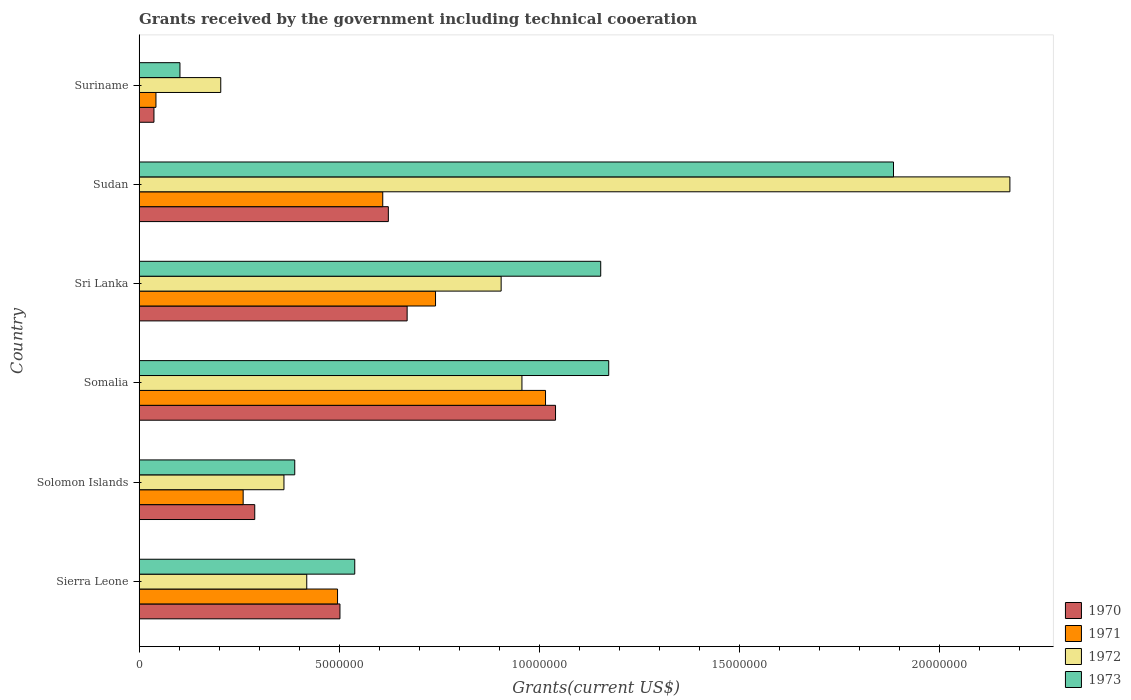How many different coloured bars are there?
Your answer should be very brief. 4. How many groups of bars are there?
Your answer should be very brief. 6. Are the number of bars per tick equal to the number of legend labels?
Provide a succinct answer. Yes. What is the label of the 6th group of bars from the top?
Offer a very short reply. Sierra Leone. In how many cases, is the number of bars for a given country not equal to the number of legend labels?
Offer a very short reply. 0. What is the total grants received by the government in 1970 in Sri Lanka?
Your answer should be very brief. 6.70e+06. Across all countries, what is the maximum total grants received by the government in 1970?
Offer a terse response. 1.04e+07. Across all countries, what is the minimum total grants received by the government in 1970?
Give a very brief answer. 3.70e+05. In which country was the total grants received by the government in 1972 maximum?
Offer a very short reply. Sudan. In which country was the total grants received by the government in 1972 minimum?
Ensure brevity in your answer.  Suriname. What is the total total grants received by the government in 1971 in the graph?
Offer a terse response. 3.16e+07. What is the difference between the total grants received by the government in 1973 in Sierra Leone and that in Sudan?
Your answer should be compact. -1.35e+07. What is the difference between the total grants received by the government in 1970 in Suriname and the total grants received by the government in 1971 in Sierra Leone?
Make the answer very short. -4.59e+06. What is the average total grants received by the government in 1972 per country?
Your answer should be very brief. 8.37e+06. What is the ratio of the total grants received by the government in 1973 in Sri Lanka to that in Sudan?
Your answer should be very brief. 0.61. What is the difference between the highest and the second highest total grants received by the government in 1973?
Your answer should be compact. 7.12e+06. What is the difference between the highest and the lowest total grants received by the government in 1971?
Provide a short and direct response. 9.74e+06. Is the sum of the total grants received by the government in 1973 in Sierra Leone and Sudan greater than the maximum total grants received by the government in 1972 across all countries?
Keep it short and to the point. Yes. Is it the case that in every country, the sum of the total grants received by the government in 1971 and total grants received by the government in 1973 is greater than the total grants received by the government in 1970?
Offer a terse response. Yes. What is the difference between two consecutive major ticks on the X-axis?
Provide a succinct answer. 5.00e+06. Are the values on the major ticks of X-axis written in scientific E-notation?
Offer a terse response. No. Does the graph contain any zero values?
Make the answer very short. No. Where does the legend appear in the graph?
Offer a terse response. Bottom right. How many legend labels are there?
Keep it short and to the point. 4. What is the title of the graph?
Keep it short and to the point. Grants received by the government including technical cooeration. Does "1961" appear as one of the legend labels in the graph?
Your answer should be very brief. No. What is the label or title of the X-axis?
Ensure brevity in your answer.  Grants(current US$). What is the label or title of the Y-axis?
Offer a terse response. Country. What is the Grants(current US$) in 1970 in Sierra Leone?
Your answer should be very brief. 5.02e+06. What is the Grants(current US$) in 1971 in Sierra Leone?
Keep it short and to the point. 4.96e+06. What is the Grants(current US$) of 1972 in Sierra Leone?
Make the answer very short. 4.19e+06. What is the Grants(current US$) of 1973 in Sierra Leone?
Offer a very short reply. 5.39e+06. What is the Grants(current US$) in 1970 in Solomon Islands?
Make the answer very short. 2.89e+06. What is the Grants(current US$) in 1971 in Solomon Islands?
Provide a succinct answer. 2.60e+06. What is the Grants(current US$) in 1972 in Solomon Islands?
Offer a terse response. 3.62e+06. What is the Grants(current US$) of 1973 in Solomon Islands?
Ensure brevity in your answer.  3.89e+06. What is the Grants(current US$) in 1970 in Somalia?
Make the answer very short. 1.04e+07. What is the Grants(current US$) of 1971 in Somalia?
Make the answer very short. 1.02e+07. What is the Grants(current US$) of 1972 in Somalia?
Ensure brevity in your answer.  9.57e+06. What is the Grants(current US$) in 1973 in Somalia?
Offer a terse response. 1.17e+07. What is the Grants(current US$) of 1970 in Sri Lanka?
Provide a short and direct response. 6.70e+06. What is the Grants(current US$) of 1971 in Sri Lanka?
Provide a succinct answer. 7.41e+06. What is the Grants(current US$) of 1972 in Sri Lanka?
Your answer should be very brief. 9.05e+06. What is the Grants(current US$) in 1973 in Sri Lanka?
Offer a terse response. 1.15e+07. What is the Grants(current US$) in 1970 in Sudan?
Your answer should be very brief. 6.23e+06. What is the Grants(current US$) in 1971 in Sudan?
Provide a succinct answer. 6.09e+06. What is the Grants(current US$) of 1972 in Sudan?
Offer a terse response. 2.18e+07. What is the Grants(current US$) in 1973 in Sudan?
Keep it short and to the point. 1.89e+07. What is the Grants(current US$) in 1970 in Suriname?
Your answer should be compact. 3.70e+05. What is the Grants(current US$) of 1971 in Suriname?
Give a very brief answer. 4.20e+05. What is the Grants(current US$) in 1972 in Suriname?
Your response must be concise. 2.04e+06. What is the Grants(current US$) of 1973 in Suriname?
Provide a succinct answer. 1.02e+06. Across all countries, what is the maximum Grants(current US$) of 1970?
Your answer should be very brief. 1.04e+07. Across all countries, what is the maximum Grants(current US$) in 1971?
Offer a terse response. 1.02e+07. Across all countries, what is the maximum Grants(current US$) in 1972?
Make the answer very short. 2.18e+07. Across all countries, what is the maximum Grants(current US$) of 1973?
Ensure brevity in your answer.  1.89e+07. Across all countries, what is the minimum Grants(current US$) in 1970?
Give a very brief answer. 3.70e+05. Across all countries, what is the minimum Grants(current US$) in 1971?
Make the answer very short. 4.20e+05. Across all countries, what is the minimum Grants(current US$) in 1972?
Provide a short and direct response. 2.04e+06. Across all countries, what is the minimum Grants(current US$) of 1973?
Make the answer very short. 1.02e+06. What is the total Grants(current US$) of 1970 in the graph?
Ensure brevity in your answer.  3.16e+07. What is the total Grants(current US$) in 1971 in the graph?
Provide a short and direct response. 3.16e+07. What is the total Grants(current US$) in 1972 in the graph?
Provide a short and direct response. 5.02e+07. What is the total Grants(current US$) in 1973 in the graph?
Offer a terse response. 5.24e+07. What is the difference between the Grants(current US$) in 1970 in Sierra Leone and that in Solomon Islands?
Provide a short and direct response. 2.13e+06. What is the difference between the Grants(current US$) of 1971 in Sierra Leone and that in Solomon Islands?
Your response must be concise. 2.36e+06. What is the difference between the Grants(current US$) of 1972 in Sierra Leone and that in Solomon Islands?
Provide a short and direct response. 5.70e+05. What is the difference between the Grants(current US$) of 1973 in Sierra Leone and that in Solomon Islands?
Give a very brief answer. 1.50e+06. What is the difference between the Grants(current US$) of 1970 in Sierra Leone and that in Somalia?
Your response must be concise. -5.39e+06. What is the difference between the Grants(current US$) in 1971 in Sierra Leone and that in Somalia?
Make the answer very short. -5.20e+06. What is the difference between the Grants(current US$) of 1972 in Sierra Leone and that in Somalia?
Make the answer very short. -5.38e+06. What is the difference between the Grants(current US$) in 1973 in Sierra Leone and that in Somalia?
Your answer should be compact. -6.35e+06. What is the difference between the Grants(current US$) in 1970 in Sierra Leone and that in Sri Lanka?
Provide a succinct answer. -1.68e+06. What is the difference between the Grants(current US$) in 1971 in Sierra Leone and that in Sri Lanka?
Make the answer very short. -2.45e+06. What is the difference between the Grants(current US$) in 1972 in Sierra Leone and that in Sri Lanka?
Give a very brief answer. -4.86e+06. What is the difference between the Grants(current US$) in 1973 in Sierra Leone and that in Sri Lanka?
Provide a short and direct response. -6.15e+06. What is the difference between the Grants(current US$) of 1970 in Sierra Leone and that in Sudan?
Ensure brevity in your answer.  -1.21e+06. What is the difference between the Grants(current US$) of 1971 in Sierra Leone and that in Sudan?
Provide a succinct answer. -1.13e+06. What is the difference between the Grants(current US$) in 1972 in Sierra Leone and that in Sudan?
Your answer should be very brief. -1.76e+07. What is the difference between the Grants(current US$) of 1973 in Sierra Leone and that in Sudan?
Provide a short and direct response. -1.35e+07. What is the difference between the Grants(current US$) of 1970 in Sierra Leone and that in Suriname?
Offer a terse response. 4.65e+06. What is the difference between the Grants(current US$) of 1971 in Sierra Leone and that in Suriname?
Keep it short and to the point. 4.54e+06. What is the difference between the Grants(current US$) in 1972 in Sierra Leone and that in Suriname?
Your response must be concise. 2.15e+06. What is the difference between the Grants(current US$) in 1973 in Sierra Leone and that in Suriname?
Ensure brevity in your answer.  4.37e+06. What is the difference between the Grants(current US$) of 1970 in Solomon Islands and that in Somalia?
Your answer should be very brief. -7.52e+06. What is the difference between the Grants(current US$) in 1971 in Solomon Islands and that in Somalia?
Offer a very short reply. -7.56e+06. What is the difference between the Grants(current US$) of 1972 in Solomon Islands and that in Somalia?
Ensure brevity in your answer.  -5.95e+06. What is the difference between the Grants(current US$) in 1973 in Solomon Islands and that in Somalia?
Offer a terse response. -7.85e+06. What is the difference between the Grants(current US$) of 1970 in Solomon Islands and that in Sri Lanka?
Keep it short and to the point. -3.81e+06. What is the difference between the Grants(current US$) in 1971 in Solomon Islands and that in Sri Lanka?
Your answer should be compact. -4.81e+06. What is the difference between the Grants(current US$) in 1972 in Solomon Islands and that in Sri Lanka?
Your answer should be very brief. -5.43e+06. What is the difference between the Grants(current US$) of 1973 in Solomon Islands and that in Sri Lanka?
Offer a terse response. -7.65e+06. What is the difference between the Grants(current US$) in 1970 in Solomon Islands and that in Sudan?
Provide a short and direct response. -3.34e+06. What is the difference between the Grants(current US$) in 1971 in Solomon Islands and that in Sudan?
Provide a short and direct response. -3.49e+06. What is the difference between the Grants(current US$) of 1972 in Solomon Islands and that in Sudan?
Make the answer very short. -1.82e+07. What is the difference between the Grants(current US$) of 1973 in Solomon Islands and that in Sudan?
Your answer should be very brief. -1.50e+07. What is the difference between the Grants(current US$) in 1970 in Solomon Islands and that in Suriname?
Your response must be concise. 2.52e+06. What is the difference between the Grants(current US$) of 1971 in Solomon Islands and that in Suriname?
Keep it short and to the point. 2.18e+06. What is the difference between the Grants(current US$) of 1972 in Solomon Islands and that in Suriname?
Your response must be concise. 1.58e+06. What is the difference between the Grants(current US$) of 1973 in Solomon Islands and that in Suriname?
Keep it short and to the point. 2.87e+06. What is the difference between the Grants(current US$) of 1970 in Somalia and that in Sri Lanka?
Ensure brevity in your answer.  3.71e+06. What is the difference between the Grants(current US$) in 1971 in Somalia and that in Sri Lanka?
Ensure brevity in your answer.  2.75e+06. What is the difference between the Grants(current US$) in 1972 in Somalia and that in Sri Lanka?
Ensure brevity in your answer.  5.20e+05. What is the difference between the Grants(current US$) of 1973 in Somalia and that in Sri Lanka?
Provide a succinct answer. 2.00e+05. What is the difference between the Grants(current US$) of 1970 in Somalia and that in Sudan?
Ensure brevity in your answer.  4.18e+06. What is the difference between the Grants(current US$) in 1971 in Somalia and that in Sudan?
Keep it short and to the point. 4.07e+06. What is the difference between the Grants(current US$) in 1972 in Somalia and that in Sudan?
Provide a short and direct response. -1.22e+07. What is the difference between the Grants(current US$) of 1973 in Somalia and that in Sudan?
Keep it short and to the point. -7.12e+06. What is the difference between the Grants(current US$) in 1970 in Somalia and that in Suriname?
Offer a terse response. 1.00e+07. What is the difference between the Grants(current US$) in 1971 in Somalia and that in Suriname?
Keep it short and to the point. 9.74e+06. What is the difference between the Grants(current US$) in 1972 in Somalia and that in Suriname?
Provide a succinct answer. 7.53e+06. What is the difference between the Grants(current US$) of 1973 in Somalia and that in Suriname?
Your answer should be very brief. 1.07e+07. What is the difference between the Grants(current US$) in 1971 in Sri Lanka and that in Sudan?
Give a very brief answer. 1.32e+06. What is the difference between the Grants(current US$) in 1972 in Sri Lanka and that in Sudan?
Make the answer very short. -1.27e+07. What is the difference between the Grants(current US$) of 1973 in Sri Lanka and that in Sudan?
Offer a very short reply. -7.32e+06. What is the difference between the Grants(current US$) in 1970 in Sri Lanka and that in Suriname?
Your answer should be very brief. 6.33e+06. What is the difference between the Grants(current US$) in 1971 in Sri Lanka and that in Suriname?
Keep it short and to the point. 6.99e+06. What is the difference between the Grants(current US$) in 1972 in Sri Lanka and that in Suriname?
Your answer should be compact. 7.01e+06. What is the difference between the Grants(current US$) of 1973 in Sri Lanka and that in Suriname?
Give a very brief answer. 1.05e+07. What is the difference between the Grants(current US$) in 1970 in Sudan and that in Suriname?
Your answer should be very brief. 5.86e+06. What is the difference between the Grants(current US$) of 1971 in Sudan and that in Suriname?
Offer a very short reply. 5.67e+06. What is the difference between the Grants(current US$) of 1972 in Sudan and that in Suriname?
Ensure brevity in your answer.  1.97e+07. What is the difference between the Grants(current US$) of 1973 in Sudan and that in Suriname?
Ensure brevity in your answer.  1.78e+07. What is the difference between the Grants(current US$) in 1970 in Sierra Leone and the Grants(current US$) in 1971 in Solomon Islands?
Your answer should be very brief. 2.42e+06. What is the difference between the Grants(current US$) of 1970 in Sierra Leone and the Grants(current US$) of 1972 in Solomon Islands?
Offer a terse response. 1.40e+06. What is the difference between the Grants(current US$) of 1970 in Sierra Leone and the Grants(current US$) of 1973 in Solomon Islands?
Your answer should be very brief. 1.13e+06. What is the difference between the Grants(current US$) of 1971 in Sierra Leone and the Grants(current US$) of 1972 in Solomon Islands?
Make the answer very short. 1.34e+06. What is the difference between the Grants(current US$) in 1971 in Sierra Leone and the Grants(current US$) in 1973 in Solomon Islands?
Provide a short and direct response. 1.07e+06. What is the difference between the Grants(current US$) in 1972 in Sierra Leone and the Grants(current US$) in 1973 in Solomon Islands?
Make the answer very short. 3.00e+05. What is the difference between the Grants(current US$) in 1970 in Sierra Leone and the Grants(current US$) in 1971 in Somalia?
Provide a succinct answer. -5.14e+06. What is the difference between the Grants(current US$) of 1970 in Sierra Leone and the Grants(current US$) of 1972 in Somalia?
Your answer should be compact. -4.55e+06. What is the difference between the Grants(current US$) of 1970 in Sierra Leone and the Grants(current US$) of 1973 in Somalia?
Offer a terse response. -6.72e+06. What is the difference between the Grants(current US$) in 1971 in Sierra Leone and the Grants(current US$) in 1972 in Somalia?
Offer a terse response. -4.61e+06. What is the difference between the Grants(current US$) in 1971 in Sierra Leone and the Grants(current US$) in 1973 in Somalia?
Provide a short and direct response. -6.78e+06. What is the difference between the Grants(current US$) of 1972 in Sierra Leone and the Grants(current US$) of 1973 in Somalia?
Your response must be concise. -7.55e+06. What is the difference between the Grants(current US$) of 1970 in Sierra Leone and the Grants(current US$) of 1971 in Sri Lanka?
Give a very brief answer. -2.39e+06. What is the difference between the Grants(current US$) of 1970 in Sierra Leone and the Grants(current US$) of 1972 in Sri Lanka?
Ensure brevity in your answer.  -4.03e+06. What is the difference between the Grants(current US$) in 1970 in Sierra Leone and the Grants(current US$) in 1973 in Sri Lanka?
Keep it short and to the point. -6.52e+06. What is the difference between the Grants(current US$) in 1971 in Sierra Leone and the Grants(current US$) in 1972 in Sri Lanka?
Your response must be concise. -4.09e+06. What is the difference between the Grants(current US$) of 1971 in Sierra Leone and the Grants(current US$) of 1973 in Sri Lanka?
Offer a very short reply. -6.58e+06. What is the difference between the Grants(current US$) in 1972 in Sierra Leone and the Grants(current US$) in 1973 in Sri Lanka?
Your response must be concise. -7.35e+06. What is the difference between the Grants(current US$) in 1970 in Sierra Leone and the Grants(current US$) in 1971 in Sudan?
Provide a short and direct response. -1.07e+06. What is the difference between the Grants(current US$) in 1970 in Sierra Leone and the Grants(current US$) in 1972 in Sudan?
Your response must be concise. -1.68e+07. What is the difference between the Grants(current US$) in 1970 in Sierra Leone and the Grants(current US$) in 1973 in Sudan?
Your response must be concise. -1.38e+07. What is the difference between the Grants(current US$) of 1971 in Sierra Leone and the Grants(current US$) of 1972 in Sudan?
Make the answer very short. -1.68e+07. What is the difference between the Grants(current US$) in 1971 in Sierra Leone and the Grants(current US$) in 1973 in Sudan?
Offer a terse response. -1.39e+07. What is the difference between the Grants(current US$) in 1972 in Sierra Leone and the Grants(current US$) in 1973 in Sudan?
Keep it short and to the point. -1.47e+07. What is the difference between the Grants(current US$) of 1970 in Sierra Leone and the Grants(current US$) of 1971 in Suriname?
Your answer should be very brief. 4.60e+06. What is the difference between the Grants(current US$) of 1970 in Sierra Leone and the Grants(current US$) of 1972 in Suriname?
Your answer should be compact. 2.98e+06. What is the difference between the Grants(current US$) of 1970 in Sierra Leone and the Grants(current US$) of 1973 in Suriname?
Your answer should be compact. 4.00e+06. What is the difference between the Grants(current US$) of 1971 in Sierra Leone and the Grants(current US$) of 1972 in Suriname?
Keep it short and to the point. 2.92e+06. What is the difference between the Grants(current US$) in 1971 in Sierra Leone and the Grants(current US$) in 1973 in Suriname?
Your answer should be compact. 3.94e+06. What is the difference between the Grants(current US$) in 1972 in Sierra Leone and the Grants(current US$) in 1973 in Suriname?
Offer a terse response. 3.17e+06. What is the difference between the Grants(current US$) of 1970 in Solomon Islands and the Grants(current US$) of 1971 in Somalia?
Your answer should be compact. -7.27e+06. What is the difference between the Grants(current US$) of 1970 in Solomon Islands and the Grants(current US$) of 1972 in Somalia?
Ensure brevity in your answer.  -6.68e+06. What is the difference between the Grants(current US$) of 1970 in Solomon Islands and the Grants(current US$) of 1973 in Somalia?
Give a very brief answer. -8.85e+06. What is the difference between the Grants(current US$) in 1971 in Solomon Islands and the Grants(current US$) in 1972 in Somalia?
Ensure brevity in your answer.  -6.97e+06. What is the difference between the Grants(current US$) of 1971 in Solomon Islands and the Grants(current US$) of 1973 in Somalia?
Give a very brief answer. -9.14e+06. What is the difference between the Grants(current US$) of 1972 in Solomon Islands and the Grants(current US$) of 1973 in Somalia?
Offer a very short reply. -8.12e+06. What is the difference between the Grants(current US$) of 1970 in Solomon Islands and the Grants(current US$) of 1971 in Sri Lanka?
Make the answer very short. -4.52e+06. What is the difference between the Grants(current US$) of 1970 in Solomon Islands and the Grants(current US$) of 1972 in Sri Lanka?
Provide a succinct answer. -6.16e+06. What is the difference between the Grants(current US$) of 1970 in Solomon Islands and the Grants(current US$) of 1973 in Sri Lanka?
Give a very brief answer. -8.65e+06. What is the difference between the Grants(current US$) of 1971 in Solomon Islands and the Grants(current US$) of 1972 in Sri Lanka?
Keep it short and to the point. -6.45e+06. What is the difference between the Grants(current US$) of 1971 in Solomon Islands and the Grants(current US$) of 1973 in Sri Lanka?
Make the answer very short. -8.94e+06. What is the difference between the Grants(current US$) in 1972 in Solomon Islands and the Grants(current US$) in 1973 in Sri Lanka?
Your answer should be compact. -7.92e+06. What is the difference between the Grants(current US$) of 1970 in Solomon Islands and the Grants(current US$) of 1971 in Sudan?
Provide a short and direct response. -3.20e+06. What is the difference between the Grants(current US$) of 1970 in Solomon Islands and the Grants(current US$) of 1972 in Sudan?
Your response must be concise. -1.89e+07. What is the difference between the Grants(current US$) in 1970 in Solomon Islands and the Grants(current US$) in 1973 in Sudan?
Offer a terse response. -1.60e+07. What is the difference between the Grants(current US$) of 1971 in Solomon Islands and the Grants(current US$) of 1972 in Sudan?
Give a very brief answer. -1.92e+07. What is the difference between the Grants(current US$) of 1971 in Solomon Islands and the Grants(current US$) of 1973 in Sudan?
Ensure brevity in your answer.  -1.63e+07. What is the difference between the Grants(current US$) of 1972 in Solomon Islands and the Grants(current US$) of 1973 in Sudan?
Provide a succinct answer. -1.52e+07. What is the difference between the Grants(current US$) in 1970 in Solomon Islands and the Grants(current US$) in 1971 in Suriname?
Your answer should be very brief. 2.47e+06. What is the difference between the Grants(current US$) in 1970 in Solomon Islands and the Grants(current US$) in 1972 in Suriname?
Provide a short and direct response. 8.50e+05. What is the difference between the Grants(current US$) in 1970 in Solomon Islands and the Grants(current US$) in 1973 in Suriname?
Keep it short and to the point. 1.87e+06. What is the difference between the Grants(current US$) of 1971 in Solomon Islands and the Grants(current US$) of 1972 in Suriname?
Offer a very short reply. 5.60e+05. What is the difference between the Grants(current US$) in 1971 in Solomon Islands and the Grants(current US$) in 1973 in Suriname?
Provide a short and direct response. 1.58e+06. What is the difference between the Grants(current US$) of 1972 in Solomon Islands and the Grants(current US$) of 1973 in Suriname?
Provide a succinct answer. 2.60e+06. What is the difference between the Grants(current US$) of 1970 in Somalia and the Grants(current US$) of 1972 in Sri Lanka?
Keep it short and to the point. 1.36e+06. What is the difference between the Grants(current US$) of 1970 in Somalia and the Grants(current US$) of 1973 in Sri Lanka?
Ensure brevity in your answer.  -1.13e+06. What is the difference between the Grants(current US$) in 1971 in Somalia and the Grants(current US$) in 1972 in Sri Lanka?
Your answer should be very brief. 1.11e+06. What is the difference between the Grants(current US$) in 1971 in Somalia and the Grants(current US$) in 1973 in Sri Lanka?
Offer a terse response. -1.38e+06. What is the difference between the Grants(current US$) in 1972 in Somalia and the Grants(current US$) in 1973 in Sri Lanka?
Provide a succinct answer. -1.97e+06. What is the difference between the Grants(current US$) of 1970 in Somalia and the Grants(current US$) of 1971 in Sudan?
Offer a terse response. 4.32e+06. What is the difference between the Grants(current US$) in 1970 in Somalia and the Grants(current US$) in 1972 in Sudan?
Ensure brevity in your answer.  -1.14e+07. What is the difference between the Grants(current US$) of 1970 in Somalia and the Grants(current US$) of 1973 in Sudan?
Ensure brevity in your answer.  -8.45e+06. What is the difference between the Grants(current US$) of 1971 in Somalia and the Grants(current US$) of 1972 in Sudan?
Provide a short and direct response. -1.16e+07. What is the difference between the Grants(current US$) in 1971 in Somalia and the Grants(current US$) in 1973 in Sudan?
Offer a very short reply. -8.70e+06. What is the difference between the Grants(current US$) of 1972 in Somalia and the Grants(current US$) of 1973 in Sudan?
Your answer should be compact. -9.29e+06. What is the difference between the Grants(current US$) in 1970 in Somalia and the Grants(current US$) in 1971 in Suriname?
Your response must be concise. 9.99e+06. What is the difference between the Grants(current US$) in 1970 in Somalia and the Grants(current US$) in 1972 in Suriname?
Provide a succinct answer. 8.37e+06. What is the difference between the Grants(current US$) in 1970 in Somalia and the Grants(current US$) in 1973 in Suriname?
Make the answer very short. 9.39e+06. What is the difference between the Grants(current US$) in 1971 in Somalia and the Grants(current US$) in 1972 in Suriname?
Offer a terse response. 8.12e+06. What is the difference between the Grants(current US$) of 1971 in Somalia and the Grants(current US$) of 1973 in Suriname?
Make the answer very short. 9.14e+06. What is the difference between the Grants(current US$) in 1972 in Somalia and the Grants(current US$) in 1973 in Suriname?
Provide a succinct answer. 8.55e+06. What is the difference between the Grants(current US$) in 1970 in Sri Lanka and the Grants(current US$) in 1971 in Sudan?
Your answer should be compact. 6.10e+05. What is the difference between the Grants(current US$) in 1970 in Sri Lanka and the Grants(current US$) in 1972 in Sudan?
Provide a succinct answer. -1.51e+07. What is the difference between the Grants(current US$) of 1970 in Sri Lanka and the Grants(current US$) of 1973 in Sudan?
Provide a succinct answer. -1.22e+07. What is the difference between the Grants(current US$) in 1971 in Sri Lanka and the Grants(current US$) in 1972 in Sudan?
Your answer should be compact. -1.44e+07. What is the difference between the Grants(current US$) of 1971 in Sri Lanka and the Grants(current US$) of 1973 in Sudan?
Provide a short and direct response. -1.14e+07. What is the difference between the Grants(current US$) of 1972 in Sri Lanka and the Grants(current US$) of 1973 in Sudan?
Keep it short and to the point. -9.81e+06. What is the difference between the Grants(current US$) of 1970 in Sri Lanka and the Grants(current US$) of 1971 in Suriname?
Your answer should be compact. 6.28e+06. What is the difference between the Grants(current US$) in 1970 in Sri Lanka and the Grants(current US$) in 1972 in Suriname?
Provide a succinct answer. 4.66e+06. What is the difference between the Grants(current US$) in 1970 in Sri Lanka and the Grants(current US$) in 1973 in Suriname?
Provide a short and direct response. 5.68e+06. What is the difference between the Grants(current US$) of 1971 in Sri Lanka and the Grants(current US$) of 1972 in Suriname?
Your answer should be compact. 5.37e+06. What is the difference between the Grants(current US$) of 1971 in Sri Lanka and the Grants(current US$) of 1973 in Suriname?
Make the answer very short. 6.39e+06. What is the difference between the Grants(current US$) in 1972 in Sri Lanka and the Grants(current US$) in 1973 in Suriname?
Your answer should be very brief. 8.03e+06. What is the difference between the Grants(current US$) in 1970 in Sudan and the Grants(current US$) in 1971 in Suriname?
Provide a succinct answer. 5.81e+06. What is the difference between the Grants(current US$) of 1970 in Sudan and the Grants(current US$) of 1972 in Suriname?
Your response must be concise. 4.19e+06. What is the difference between the Grants(current US$) of 1970 in Sudan and the Grants(current US$) of 1973 in Suriname?
Offer a terse response. 5.21e+06. What is the difference between the Grants(current US$) of 1971 in Sudan and the Grants(current US$) of 1972 in Suriname?
Ensure brevity in your answer.  4.05e+06. What is the difference between the Grants(current US$) in 1971 in Sudan and the Grants(current US$) in 1973 in Suriname?
Keep it short and to the point. 5.07e+06. What is the difference between the Grants(current US$) of 1972 in Sudan and the Grants(current US$) of 1973 in Suriname?
Your response must be concise. 2.08e+07. What is the average Grants(current US$) of 1970 per country?
Make the answer very short. 5.27e+06. What is the average Grants(current US$) of 1971 per country?
Your response must be concise. 5.27e+06. What is the average Grants(current US$) of 1972 per country?
Your answer should be very brief. 8.37e+06. What is the average Grants(current US$) of 1973 per country?
Give a very brief answer. 8.74e+06. What is the difference between the Grants(current US$) in 1970 and Grants(current US$) in 1972 in Sierra Leone?
Ensure brevity in your answer.  8.30e+05. What is the difference between the Grants(current US$) of 1970 and Grants(current US$) of 1973 in Sierra Leone?
Your response must be concise. -3.70e+05. What is the difference between the Grants(current US$) in 1971 and Grants(current US$) in 1972 in Sierra Leone?
Your answer should be compact. 7.70e+05. What is the difference between the Grants(current US$) of 1971 and Grants(current US$) of 1973 in Sierra Leone?
Your answer should be compact. -4.30e+05. What is the difference between the Grants(current US$) in 1972 and Grants(current US$) in 1973 in Sierra Leone?
Provide a short and direct response. -1.20e+06. What is the difference between the Grants(current US$) of 1970 and Grants(current US$) of 1971 in Solomon Islands?
Your answer should be very brief. 2.90e+05. What is the difference between the Grants(current US$) of 1970 and Grants(current US$) of 1972 in Solomon Islands?
Provide a succinct answer. -7.30e+05. What is the difference between the Grants(current US$) of 1971 and Grants(current US$) of 1972 in Solomon Islands?
Your response must be concise. -1.02e+06. What is the difference between the Grants(current US$) in 1971 and Grants(current US$) in 1973 in Solomon Islands?
Offer a very short reply. -1.29e+06. What is the difference between the Grants(current US$) in 1970 and Grants(current US$) in 1971 in Somalia?
Your response must be concise. 2.50e+05. What is the difference between the Grants(current US$) in 1970 and Grants(current US$) in 1972 in Somalia?
Offer a very short reply. 8.40e+05. What is the difference between the Grants(current US$) in 1970 and Grants(current US$) in 1973 in Somalia?
Ensure brevity in your answer.  -1.33e+06. What is the difference between the Grants(current US$) of 1971 and Grants(current US$) of 1972 in Somalia?
Your answer should be compact. 5.90e+05. What is the difference between the Grants(current US$) of 1971 and Grants(current US$) of 1973 in Somalia?
Provide a succinct answer. -1.58e+06. What is the difference between the Grants(current US$) in 1972 and Grants(current US$) in 1973 in Somalia?
Keep it short and to the point. -2.17e+06. What is the difference between the Grants(current US$) of 1970 and Grants(current US$) of 1971 in Sri Lanka?
Your answer should be compact. -7.10e+05. What is the difference between the Grants(current US$) of 1970 and Grants(current US$) of 1972 in Sri Lanka?
Your answer should be compact. -2.35e+06. What is the difference between the Grants(current US$) of 1970 and Grants(current US$) of 1973 in Sri Lanka?
Your answer should be very brief. -4.84e+06. What is the difference between the Grants(current US$) of 1971 and Grants(current US$) of 1972 in Sri Lanka?
Offer a terse response. -1.64e+06. What is the difference between the Grants(current US$) in 1971 and Grants(current US$) in 1973 in Sri Lanka?
Give a very brief answer. -4.13e+06. What is the difference between the Grants(current US$) of 1972 and Grants(current US$) of 1973 in Sri Lanka?
Make the answer very short. -2.49e+06. What is the difference between the Grants(current US$) in 1970 and Grants(current US$) in 1972 in Sudan?
Offer a terse response. -1.55e+07. What is the difference between the Grants(current US$) of 1970 and Grants(current US$) of 1973 in Sudan?
Ensure brevity in your answer.  -1.26e+07. What is the difference between the Grants(current US$) in 1971 and Grants(current US$) in 1972 in Sudan?
Your answer should be compact. -1.57e+07. What is the difference between the Grants(current US$) of 1971 and Grants(current US$) of 1973 in Sudan?
Your response must be concise. -1.28e+07. What is the difference between the Grants(current US$) of 1972 and Grants(current US$) of 1973 in Sudan?
Ensure brevity in your answer.  2.91e+06. What is the difference between the Grants(current US$) of 1970 and Grants(current US$) of 1971 in Suriname?
Ensure brevity in your answer.  -5.00e+04. What is the difference between the Grants(current US$) of 1970 and Grants(current US$) of 1972 in Suriname?
Keep it short and to the point. -1.67e+06. What is the difference between the Grants(current US$) of 1970 and Grants(current US$) of 1973 in Suriname?
Give a very brief answer. -6.50e+05. What is the difference between the Grants(current US$) of 1971 and Grants(current US$) of 1972 in Suriname?
Give a very brief answer. -1.62e+06. What is the difference between the Grants(current US$) in 1971 and Grants(current US$) in 1973 in Suriname?
Provide a short and direct response. -6.00e+05. What is the difference between the Grants(current US$) of 1972 and Grants(current US$) of 1973 in Suriname?
Your response must be concise. 1.02e+06. What is the ratio of the Grants(current US$) in 1970 in Sierra Leone to that in Solomon Islands?
Offer a very short reply. 1.74. What is the ratio of the Grants(current US$) of 1971 in Sierra Leone to that in Solomon Islands?
Give a very brief answer. 1.91. What is the ratio of the Grants(current US$) in 1972 in Sierra Leone to that in Solomon Islands?
Your response must be concise. 1.16. What is the ratio of the Grants(current US$) of 1973 in Sierra Leone to that in Solomon Islands?
Ensure brevity in your answer.  1.39. What is the ratio of the Grants(current US$) in 1970 in Sierra Leone to that in Somalia?
Your response must be concise. 0.48. What is the ratio of the Grants(current US$) of 1971 in Sierra Leone to that in Somalia?
Give a very brief answer. 0.49. What is the ratio of the Grants(current US$) in 1972 in Sierra Leone to that in Somalia?
Provide a short and direct response. 0.44. What is the ratio of the Grants(current US$) in 1973 in Sierra Leone to that in Somalia?
Give a very brief answer. 0.46. What is the ratio of the Grants(current US$) in 1970 in Sierra Leone to that in Sri Lanka?
Keep it short and to the point. 0.75. What is the ratio of the Grants(current US$) in 1971 in Sierra Leone to that in Sri Lanka?
Provide a succinct answer. 0.67. What is the ratio of the Grants(current US$) in 1972 in Sierra Leone to that in Sri Lanka?
Keep it short and to the point. 0.46. What is the ratio of the Grants(current US$) of 1973 in Sierra Leone to that in Sri Lanka?
Offer a terse response. 0.47. What is the ratio of the Grants(current US$) of 1970 in Sierra Leone to that in Sudan?
Offer a very short reply. 0.81. What is the ratio of the Grants(current US$) of 1971 in Sierra Leone to that in Sudan?
Offer a terse response. 0.81. What is the ratio of the Grants(current US$) in 1972 in Sierra Leone to that in Sudan?
Your answer should be compact. 0.19. What is the ratio of the Grants(current US$) of 1973 in Sierra Leone to that in Sudan?
Ensure brevity in your answer.  0.29. What is the ratio of the Grants(current US$) in 1970 in Sierra Leone to that in Suriname?
Keep it short and to the point. 13.57. What is the ratio of the Grants(current US$) in 1971 in Sierra Leone to that in Suriname?
Make the answer very short. 11.81. What is the ratio of the Grants(current US$) of 1972 in Sierra Leone to that in Suriname?
Provide a succinct answer. 2.05. What is the ratio of the Grants(current US$) in 1973 in Sierra Leone to that in Suriname?
Keep it short and to the point. 5.28. What is the ratio of the Grants(current US$) in 1970 in Solomon Islands to that in Somalia?
Your answer should be very brief. 0.28. What is the ratio of the Grants(current US$) in 1971 in Solomon Islands to that in Somalia?
Give a very brief answer. 0.26. What is the ratio of the Grants(current US$) in 1972 in Solomon Islands to that in Somalia?
Your answer should be compact. 0.38. What is the ratio of the Grants(current US$) of 1973 in Solomon Islands to that in Somalia?
Provide a short and direct response. 0.33. What is the ratio of the Grants(current US$) in 1970 in Solomon Islands to that in Sri Lanka?
Provide a short and direct response. 0.43. What is the ratio of the Grants(current US$) in 1971 in Solomon Islands to that in Sri Lanka?
Offer a very short reply. 0.35. What is the ratio of the Grants(current US$) of 1973 in Solomon Islands to that in Sri Lanka?
Make the answer very short. 0.34. What is the ratio of the Grants(current US$) of 1970 in Solomon Islands to that in Sudan?
Offer a terse response. 0.46. What is the ratio of the Grants(current US$) of 1971 in Solomon Islands to that in Sudan?
Give a very brief answer. 0.43. What is the ratio of the Grants(current US$) in 1972 in Solomon Islands to that in Sudan?
Give a very brief answer. 0.17. What is the ratio of the Grants(current US$) in 1973 in Solomon Islands to that in Sudan?
Give a very brief answer. 0.21. What is the ratio of the Grants(current US$) in 1970 in Solomon Islands to that in Suriname?
Provide a succinct answer. 7.81. What is the ratio of the Grants(current US$) in 1971 in Solomon Islands to that in Suriname?
Give a very brief answer. 6.19. What is the ratio of the Grants(current US$) in 1972 in Solomon Islands to that in Suriname?
Ensure brevity in your answer.  1.77. What is the ratio of the Grants(current US$) of 1973 in Solomon Islands to that in Suriname?
Your answer should be very brief. 3.81. What is the ratio of the Grants(current US$) of 1970 in Somalia to that in Sri Lanka?
Your answer should be very brief. 1.55. What is the ratio of the Grants(current US$) in 1971 in Somalia to that in Sri Lanka?
Provide a short and direct response. 1.37. What is the ratio of the Grants(current US$) in 1972 in Somalia to that in Sri Lanka?
Make the answer very short. 1.06. What is the ratio of the Grants(current US$) in 1973 in Somalia to that in Sri Lanka?
Your answer should be very brief. 1.02. What is the ratio of the Grants(current US$) in 1970 in Somalia to that in Sudan?
Your answer should be compact. 1.67. What is the ratio of the Grants(current US$) in 1971 in Somalia to that in Sudan?
Offer a very short reply. 1.67. What is the ratio of the Grants(current US$) of 1972 in Somalia to that in Sudan?
Offer a very short reply. 0.44. What is the ratio of the Grants(current US$) in 1973 in Somalia to that in Sudan?
Offer a very short reply. 0.62. What is the ratio of the Grants(current US$) of 1970 in Somalia to that in Suriname?
Your response must be concise. 28.14. What is the ratio of the Grants(current US$) of 1971 in Somalia to that in Suriname?
Offer a very short reply. 24.19. What is the ratio of the Grants(current US$) in 1972 in Somalia to that in Suriname?
Offer a very short reply. 4.69. What is the ratio of the Grants(current US$) of 1973 in Somalia to that in Suriname?
Offer a very short reply. 11.51. What is the ratio of the Grants(current US$) in 1970 in Sri Lanka to that in Sudan?
Your response must be concise. 1.08. What is the ratio of the Grants(current US$) in 1971 in Sri Lanka to that in Sudan?
Your answer should be very brief. 1.22. What is the ratio of the Grants(current US$) in 1972 in Sri Lanka to that in Sudan?
Give a very brief answer. 0.42. What is the ratio of the Grants(current US$) of 1973 in Sri Lanka to that in Sudan?
Offer a very short reply. 0.61. What is the ratio of the Grants(current US$) in 1970 in Sri Lanka to that in Suriname?
Your answer should be very brief. 18.11. What is the ratio of the Grants(current US$) in 1971 in Sri Lanka to that in Suriname?
Your response must be concise. 17.64. What is the ratio of the Grants(current US$) of 1972 in Sri Lanka to that in Suriname?
Ensure brevity in your answer.  4.44. What is the ratio of the Grants(current US$) in 1973 in Sri Lanka to that in Suriname?
Provide a short and direct response. 11.31. What is the ratio of the Grants(current US$) of 1970 in Sudan to that in Suriname?
Ensure brevity in your answer.  16.84. What is the ratio of the Grants(current US$) in 1971 in Sudan to that in Suriname?
Give a very brief answer. 14.5. What is the ratio of the Grants(current US$) of 1972 in Sudan to that in Suriname?
Give a very brief answer. 10.67. What is the ratio of the Grants(current US$) in 1973 in Sudan to that in Suriname?
Offer a very short reply. 18.49. What is the difference between the highest and the second highest Grants(current US$) of 1970?
Make the answer very short. 3.71e+06. What is the difference between the highest and the second highest Grants(current US$) of 1971?
Your answer should be very brief. 2.75e+06. What is the difference between the highest and the second highest Grants(current US$) of 1972?
Provide a short and direct response. 1.22e+07. What is the difference between the highest and the second highest Grants(current US$) in 1973?
Ensure brevity in your answer.  7.12e+06. What is the difference between the highest and the lowest Grants(current US$) in 1970?
Your answer should be very brief. 1.00e+07. What is the difference between the highest and the lowest Grants(current US$) in 1971?
Your answer should be compact. 9.74e+06. What is the difference between the highest and the lowest Grants(current US$) in 1972?
Offer a very short reply. 1.97e+07. What is the difference between the highest and the lowest Grants(current US$) in 1973?
Your answer should be compact. 1.78e+07. 